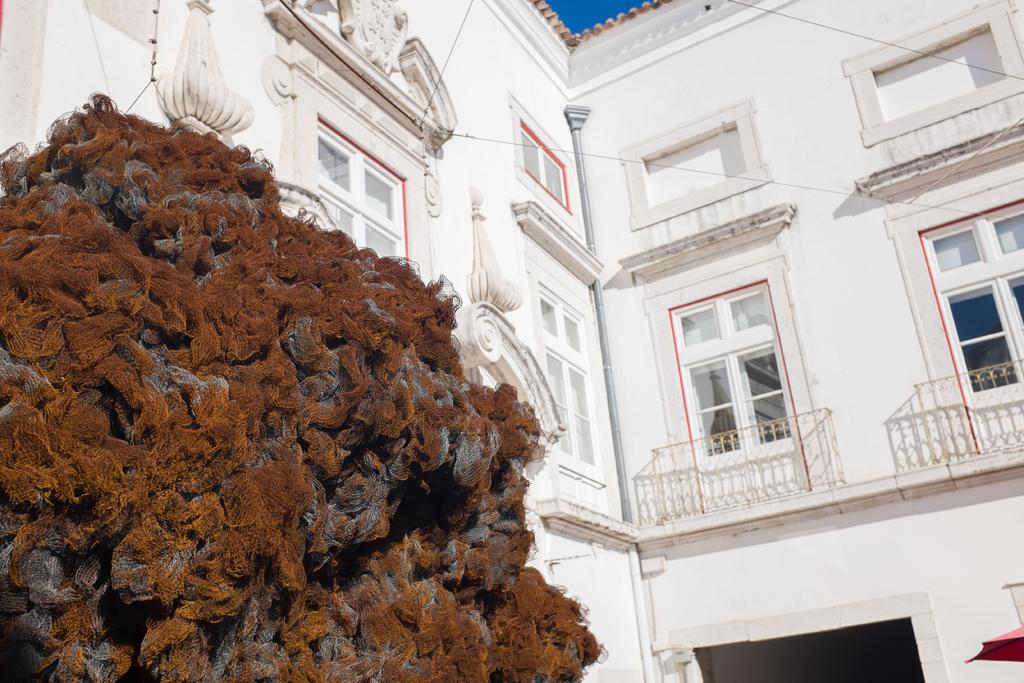What type of structure is present in the image? There is a building in the image. Where is the tree located in the image? The tree is on the left side of the image. What can be seen in the background of the image? The sky is visible in the background of the image, and there are also wires present. What type of unit is being measured in the image? There is no indication of any unit being measured in the image. Can you describe the garden in the image? There is no garden present in the image. 